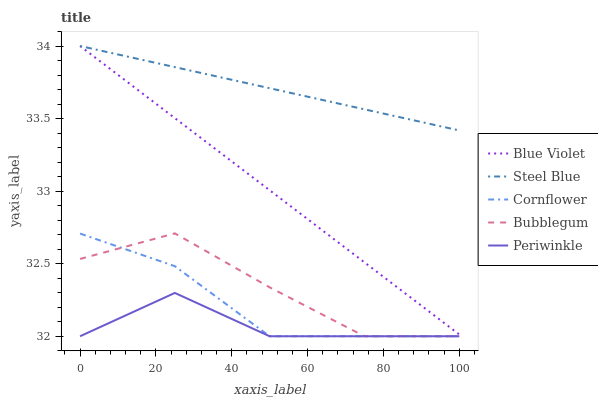Does Periwinkle have the minimum area under the curve?
Answer yes or no. Yes. Does Steel Blue have the maximum area under the curve?
Answer yes or no. Yes. Does Bubblegum have the minimum area under the curve?
Answer yes or no. No. Does Bubblegum have the maximum area under the curve?
Answer yes or no. No. Is Blue Violet the smoothest?
Answer yes or no. Yes. Is Bubblegum the roughest?
Answer yes or no. Yes. Is Periwinkle the smoothest?
Answer yes or no. No. Is Periwinkle the roughest?
Answer yes or no. No. Does Cornflower have the lowest value?
Answer yes or no. Yes. Does Steel Blue have the lowest value?
Answer yes or no. No. Does Blue Violet have the highest value?
Answer yes or no. Yes. Does Bubblegum have the highest value?
Answer yes or no. No. Is Bubblegum less than Steel Blue?
Answer yes or no. Yes. Is Blue Violet greater than Cornflower?
Answer yes or no. Yes. Does Periwinkle intersect Bubblegum?
Answer yes or no. Yes. Is Periwinkle less than Bubblegum?
Answer yes or no. No. Is Periwinkle greater than Bubblegum?
Answer yes or no. No. Does Bubblegum intersect Steel Blue?
Answer yes or no. No. 